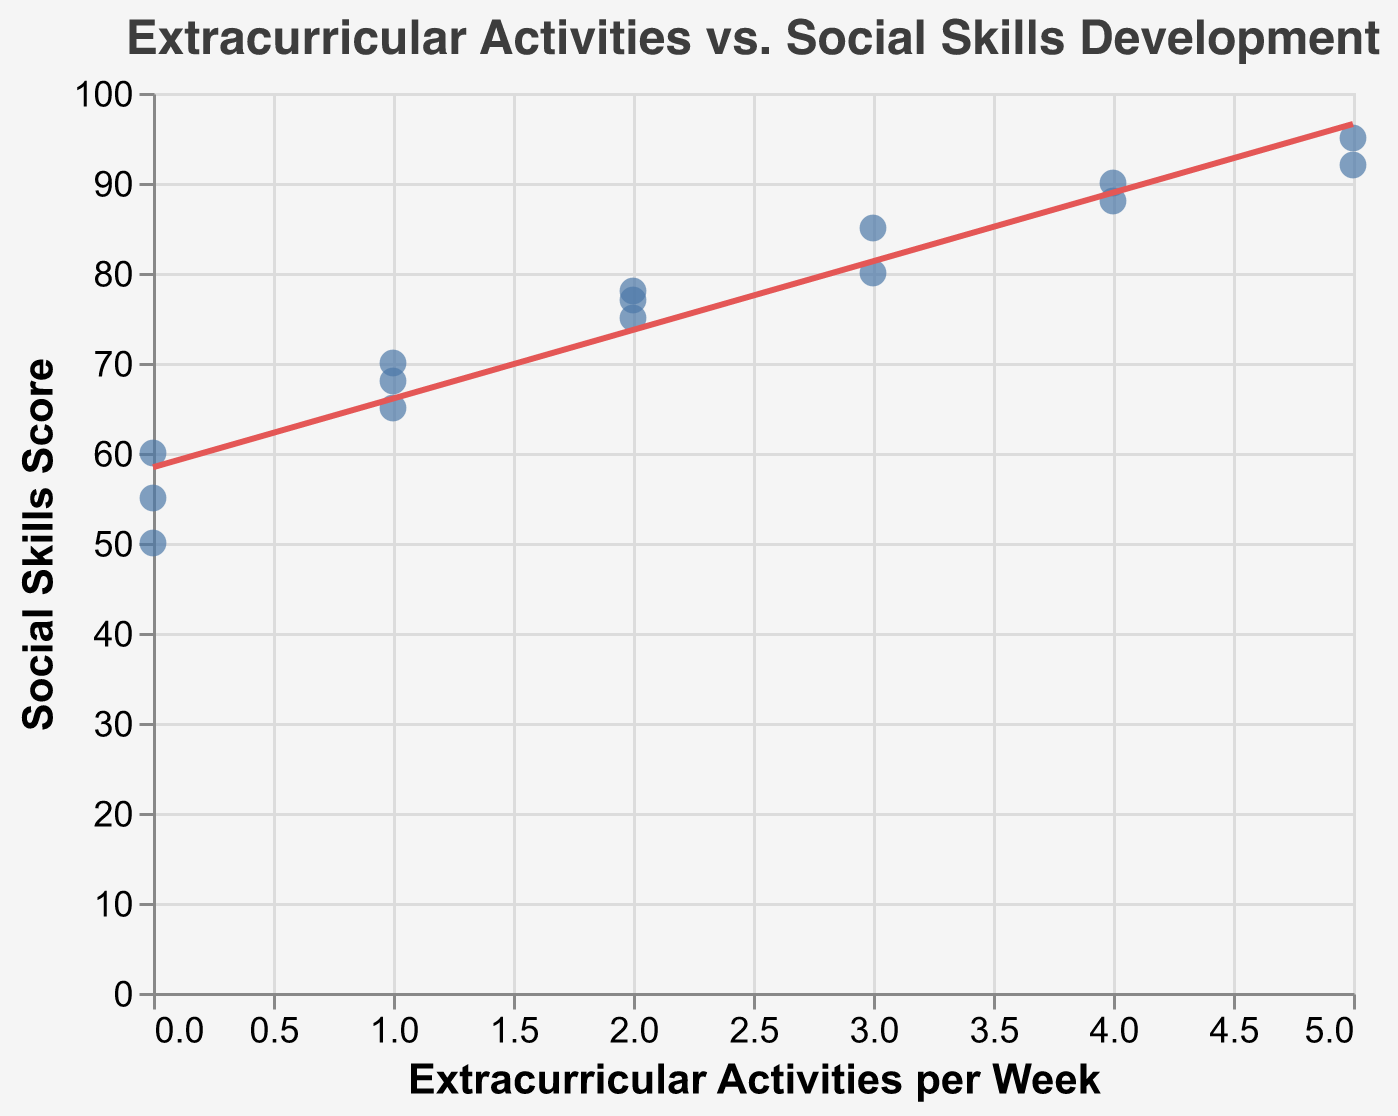What is the title of the figure? The title is displayed at the top of the figure and reads "Extracurricular Activities vs. Social Skills Development".
Answer: Extracurricular Activities vs. Social Skills Development How many students participated in 5 extracurricular activities per week? There are data points on the x-axis at 5, indicating the number of students at that point. We can see two data points at '5'.
Answer: 2 students What is the highest social skills score observed and which student achieved it? The data points with the highest position on the y-axis represent the highest social skills score. The point at y=95 is for Frank White, which is the highest score.
Answer: 95, Frank White Compare the social skills scores of students who do 0 and 1 extracurricular activity per week. Look at the points on the x-axis at 0 and 1, then compare the corresponding y values: 0 activities (50, 55, 60) and 1 activity (65, 68, 70).
Answer: Students with 1 activity generally score higher What is the general trend between extracurricular activities and social skills scores? The trend line helps us observe the general direction of the data points. The line slopes upward, indicating that more extracurricular activities are associated with higher social skills scores.
Answer: Positive correlation What is the average social skills score for students participating in 2 extracurricular activities per week? Identify the points at x=2 and calculate their average y value: (75 + 78 + 77)/3 = 76.67.
Answer: 76.67 Which student has the lowest social skills score, and how many activities do they participate in per week? Find the lowest position on the y-axis and check the corresponding x value and tooltip: Jessica Wilson at 50 with 0 activities.
Answer: Jessica Wilson, 0 activities Is there any student participating in 3 extracurricular activities per week with a social skills score below 80? Inspect the data points at x=3. Both points (80, 85) are above 80, indicating no scores below 80.
Answer: No Compare the change in social skills score from 0 to 5 extracurricular activities per week. Find the scores at x=0 (50, 55, 60) and at x=5 (92, 95). Calculate the difference: Highest gain = 95 - 60 = 35.
Answer: 35 How many data points lie below the regression line? Examine the position of data points relative to the regression line. There are six points below the line.
Answer: 6 